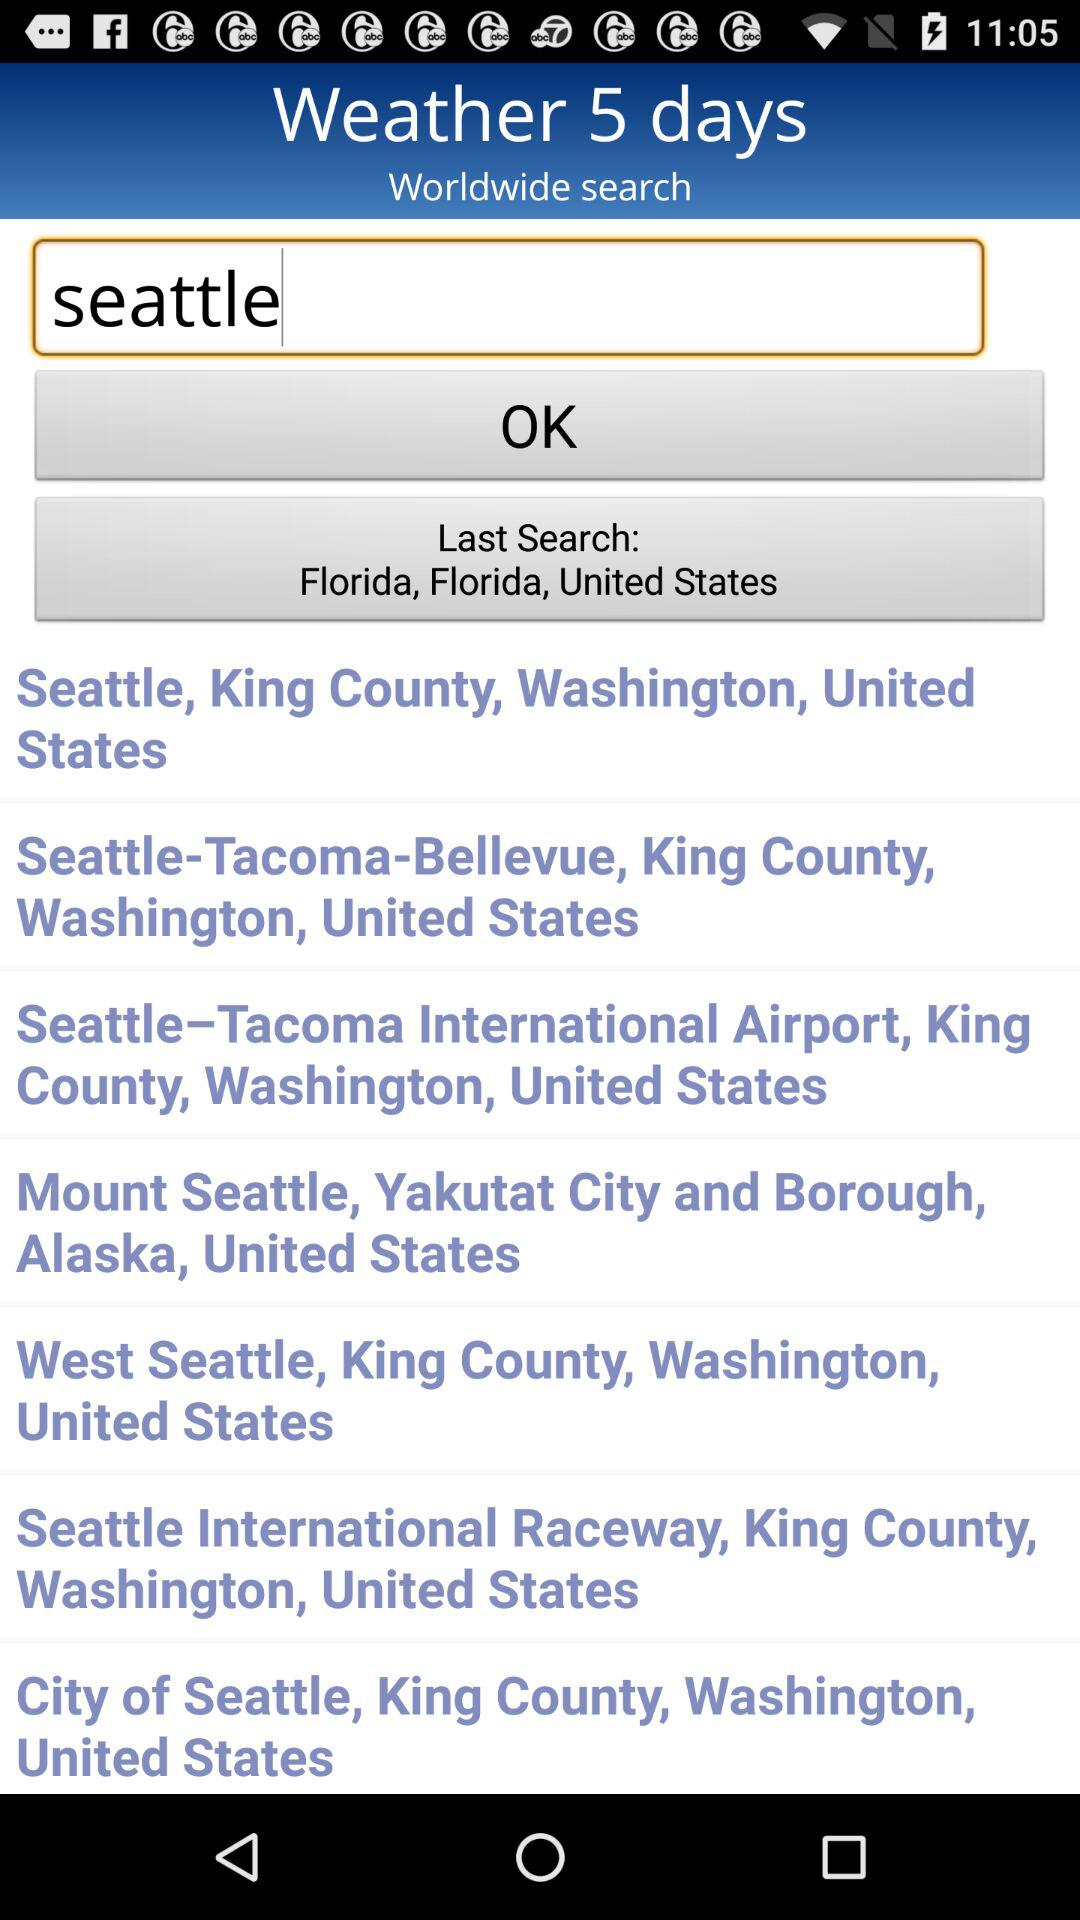What was the last searched location? The last searched location was Florida, Florida, United States. 